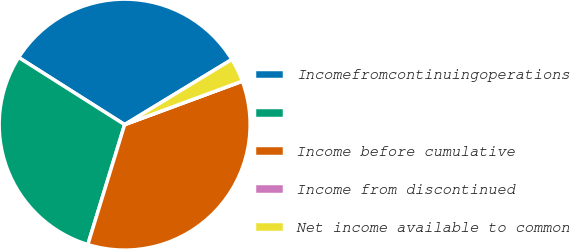Convert chart. <chart><loc_0><loc_0><loc_500><loc_500><pie_chart><fcel>Incomefromcontinuingoperations<fcel>Unnamed: 1<fcel>Income before cumulative<fcel>Income from discontinued<fcel>Net income available to common<nl><fcel>32.31%<fcel>29.25%<fcel>35.37%<fcel>0.0%<fcel>3.06%<nl></chart> 